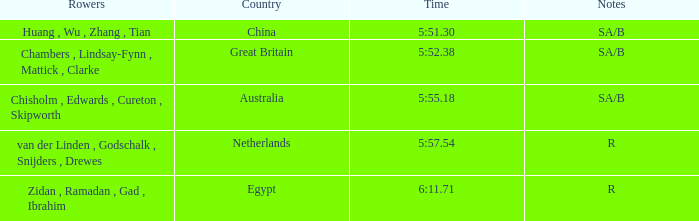Identify the rowers present when the sa/b notes took place and the time was recorded as 5:51.30. Huang , Wu , Zhang , Tian. 